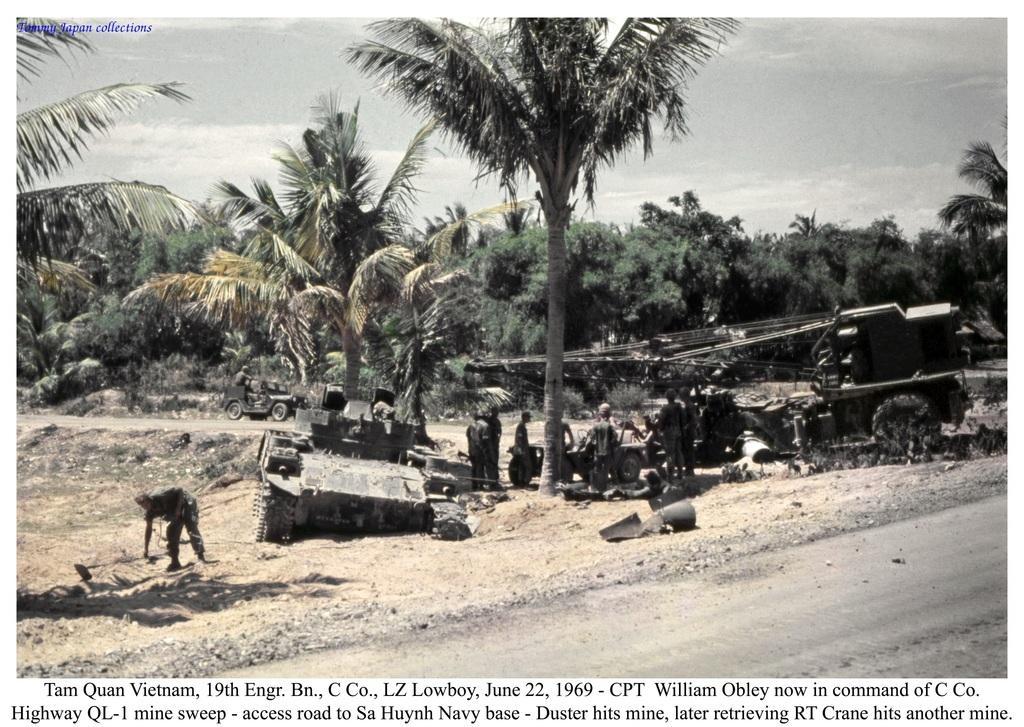Can you describe this image briefly? In this picture I can see a poster, where there are group of people, there are vehicles, trees, sky, there are some words and numbers in the poster, and there is a watermark on the image. 